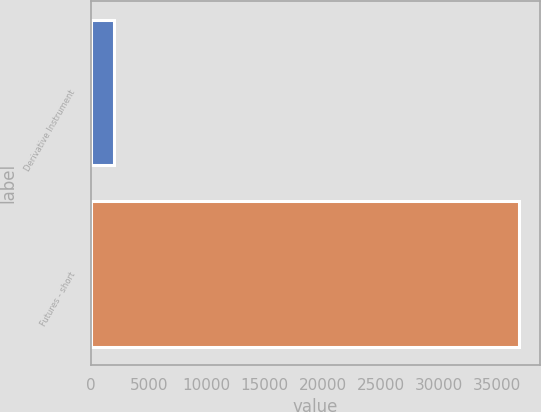Convert chart. <chart><loc_0><loc_0><loc_500><loc_500><bar_chart><fcel>Derivative Instrument<fcel>Futures - short<nl><fcel>2018<fcel>36919<nl></chart> 